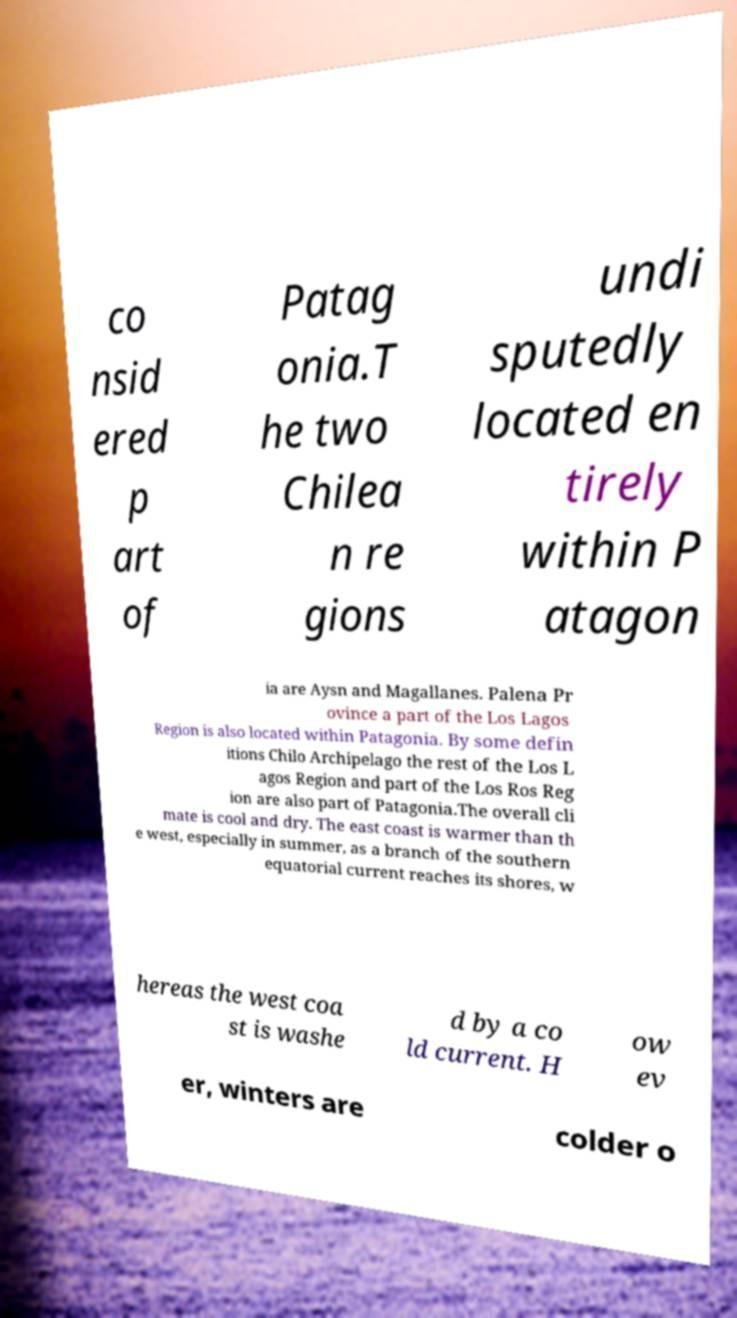Can you read and provide the text displayed in the image?This photo seems to have some interesting text. Can you extract and type it out for me? co nsid ered p art of Patag onia.T he two Chilea n re gions undi sputedly located en tirely within P atagon ia are Aysn and Magallanes. Palena Pr ovince a part of the Los Lagos Region is also located within Patagonia. By some defin itions Chilo Archipelago the rest of the Los L agos Region and part of the Los Ros Reg ion are also part of Patagonia.The overall cli mate is cool and dry. The east coast is warmer than th e west, especially in summer, as a branch of the southern equatorial current reaches its shores, w hereas the west coa st is washe d by a co ld current. H ow ev er, winters are colder o 